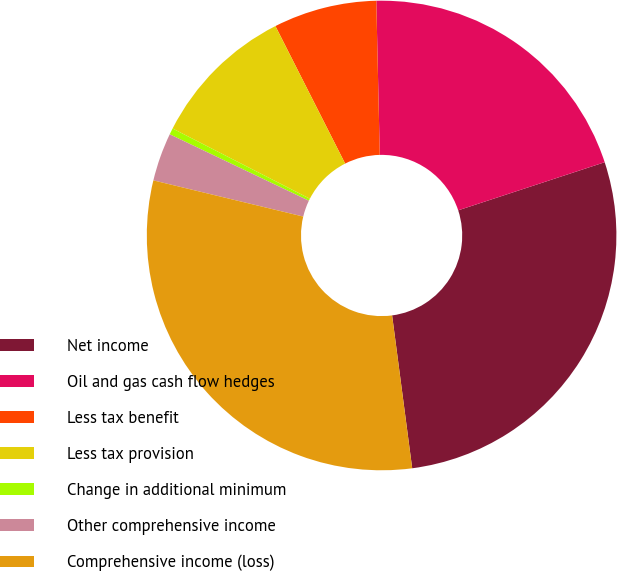Convert chart. <chart><loc_0><loc_0><loc_500><loc_500><pie_chart><fcel>Net income<fcel>Oil and gas cash flow hedges<fcel>Less tax benefit<fcel>Less tax provision<fcel>Change in additional minimum<fcel>Other comprehensive income<fcel>Comprehensive income (loss)<nl><fcel>27.97%<fcel>20.31%<fcel>7.11%<fcel>10.0%<fcel>0.44%<fcel>3.32%<fcel>30.85%<nl></chart> 